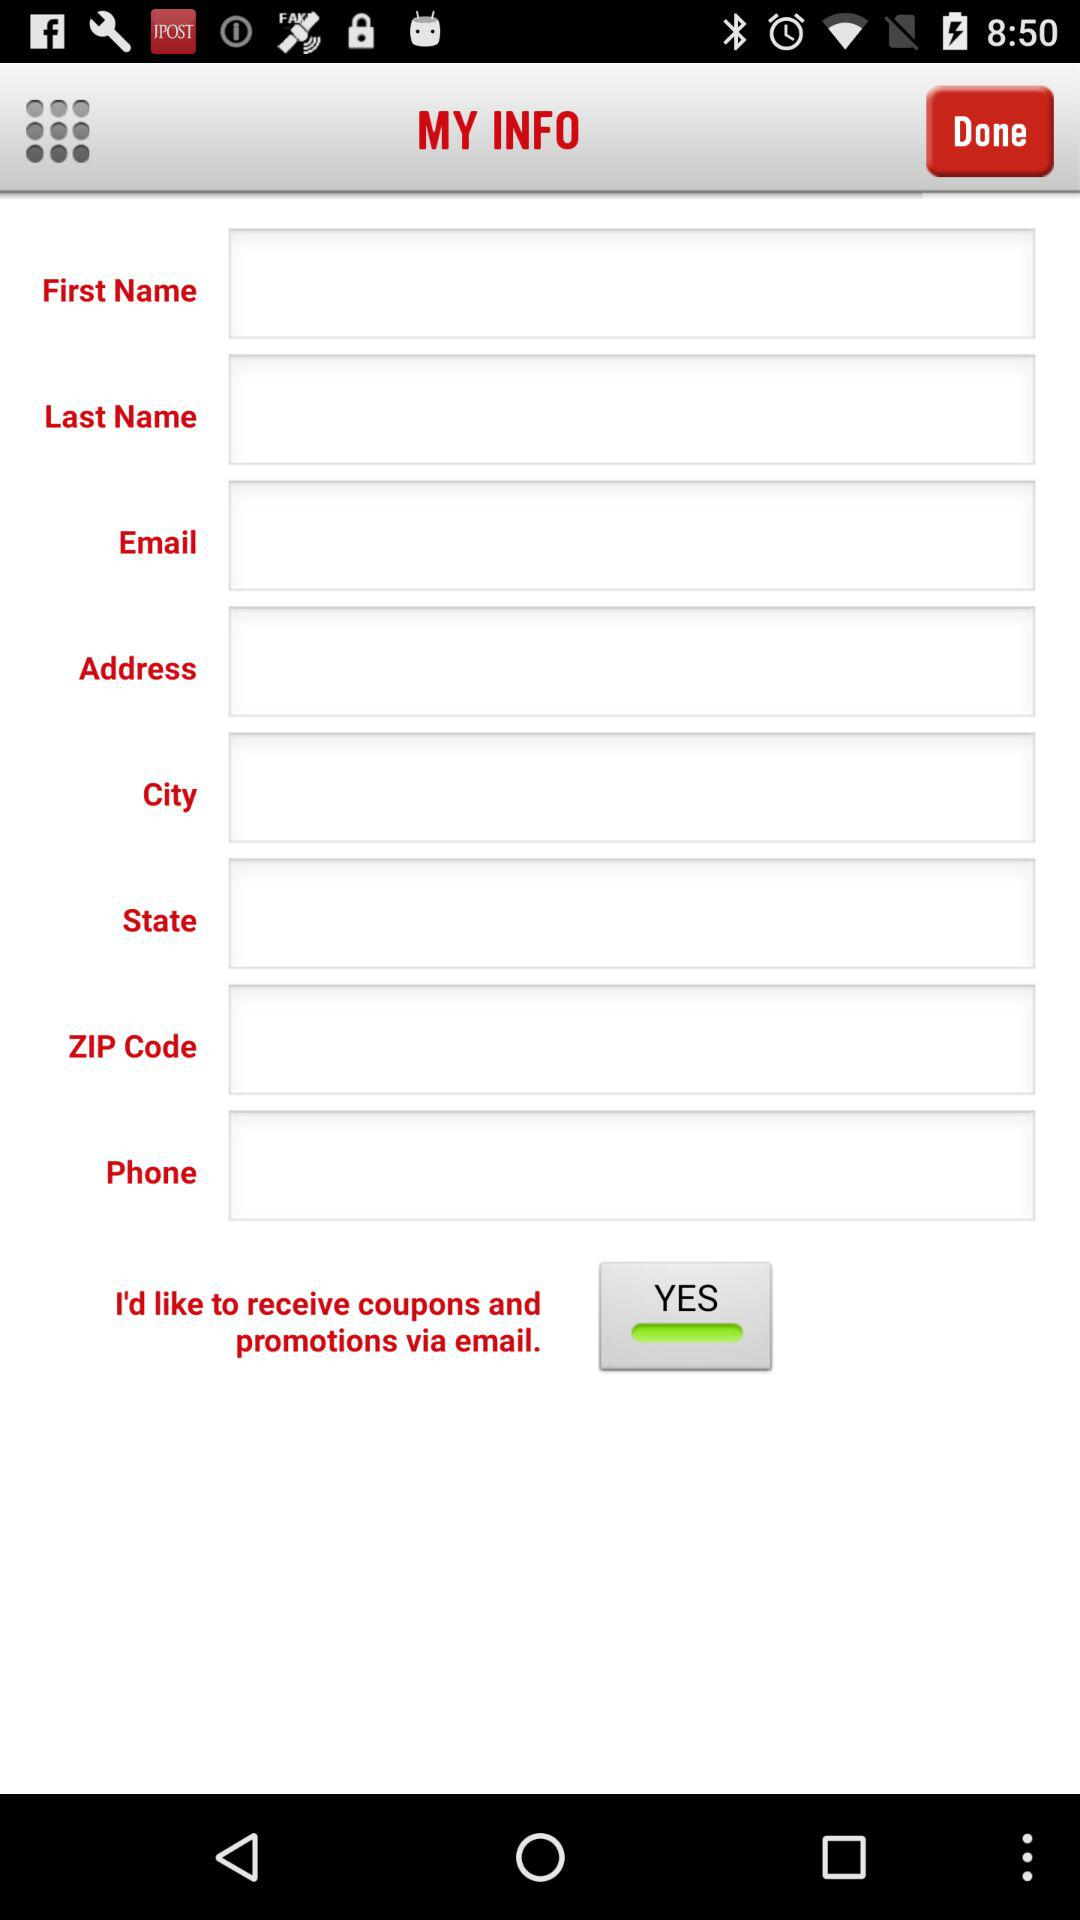How many text inputs are there for the user to enter their contact information?
Answer the question using a single word or phrase. 8 